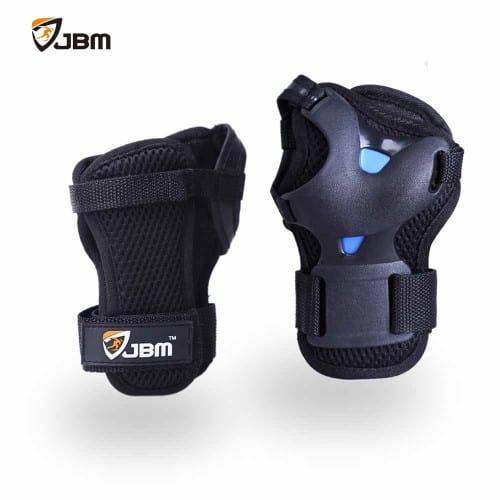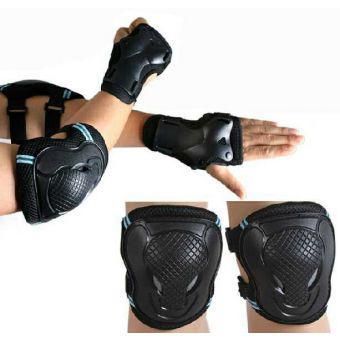The first image is the image on the left, the second image is the image on the right. Evaluate the accuracy of this statement regarding the images: "All the pads are facing right.". Is it true? Answer yes or no. No. The first image is the image on the left, the second image is the image on the right. Evaluate the accuracy of this statement regarding the images: "there are 4 knee pads in each image pair". Is it true? Answer yes or no. No. 